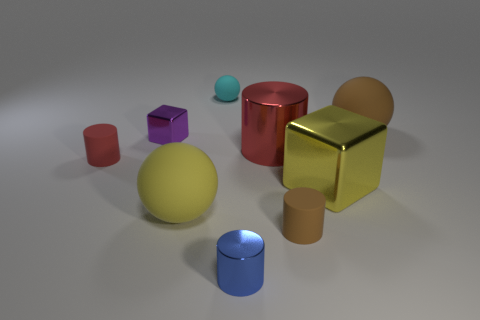What can you tell me about the lighting in this scene? The lighting in the scene appears to be coming from above, casting soft shadows directly underneath each object. This suggests an overhead, diffused light source creating a calm and evenly lit composition. Does the lighting affect the color of the objects? The lighting seems to bring out the colors vividly but does not significantly alter the hues of the objects. However, it does create subtle gradients and reflections, particularly noticeable on the metallic surfaces of the cylinders and cubes. 